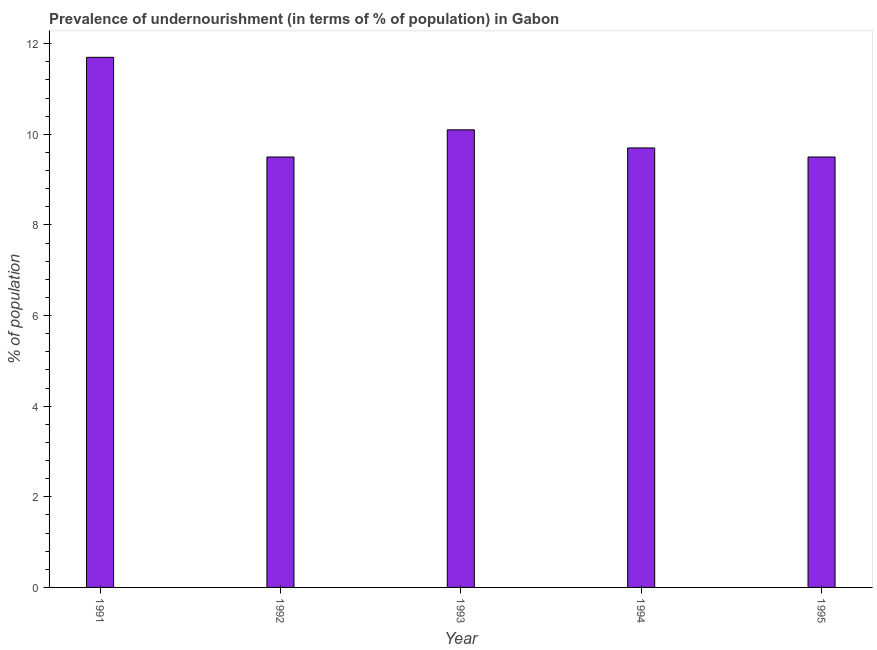What is the title of the graph?
Provide a short and direct response. Prevalence of undernourishment (in terms of % of population) in Gabon. What is the label or title of the Y-axis?
Give a very brief answer. % of population. Across all years, what is the maximum percentage of undernourished population?
Keep it short and to the point. 11.7. Across all years, what is the minimum percentage of undernourished population?
Offer a terse response. 9.5. In which year was the percentage of undernourished population minimum?
Provide a succinct answer. 1992. What is the sum of the percentage of undernourished population?
Provide a succinct answer. 50.5. What is the median percentage of undernourished population?
Provide a succinct answer. 9.7. Do a majority of the years between 1993 and 1992 (inclusive) have percentage of undernourished population greater than 2 %?
Offer a terse response. No. What is the ratio of the percentage of undernourished population in 1993 to that in 1994?
Provide a succinct answer. 1.04. Is the sum of the percentage of undernourished population in 1993 and 1995 greater than the maximum percentage of undernourished population across all years?
Ensure brevity in your answer.  Yes. In how many years, is the percentage of undernourished population greater than the average percentage of undernourished population taken over all years?
Offer a very short reply. 1. How many bars are there?
Provide a succinct answer. 5. What is the difference between two consecutive major ticks on the Y-axis?
Your answer should be compact. 2. What is the % of population in 1991?
Provide a short and direct response. 11.7. What is the difference between the % of population in 1991 and 1992?
Provide a short and direct response. 2.2. What is the difference between the % of population in 1991 and 1994?
Make the answer very short. 2. What is the difference between the % of population in 1991 and 1995?
Give a very brief answer. 2.2. What is the difference between the % of population in 1992 and 1993?
Make the answer very short. -0.6. What is the difference between the % of population in 1993 and 1994?
Keep it short and to the point. 0.4. What is the ratio of the % of population in 1991 to that in 1992?
Your answer should be very brief. 1.23. What is the ratio of the % of population in 1991 to that in 1993?
Offer a very short reply. 1.16. What is the ratio of the % of population in 1991 to that in 1994?
Keep it short and to the point. 1.21. What is the ratio of the % of population in 1991 to that in 1995?
Your response must be concise. 1.23. What is the ratio of the % of population in 1992 to that in 1993?
Provide a succinct answer. 0.94. What is the ratio of the % of population in 1992 to that in 1995?
Your response must be concise. 1. What is the ratio of the % of population in 1993 to that in 1994?
Ensure brevity in your answer.  1.04. What is the ratio of the % of population in 1993 to that in 1995?
Your answer should be compact. 1.06. 